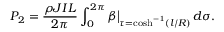<formula> <loc_0><loc_0><loc_500><loc_500>P _ { 2 } = \frac { \rho J I L } { 2 \pi } \int _ { 0 } ^ { 2 \pi } \beta \Big | _ { \tau = \cosh ^ { - 1 } ( l / R ) } \, d \sigma .</formula> 